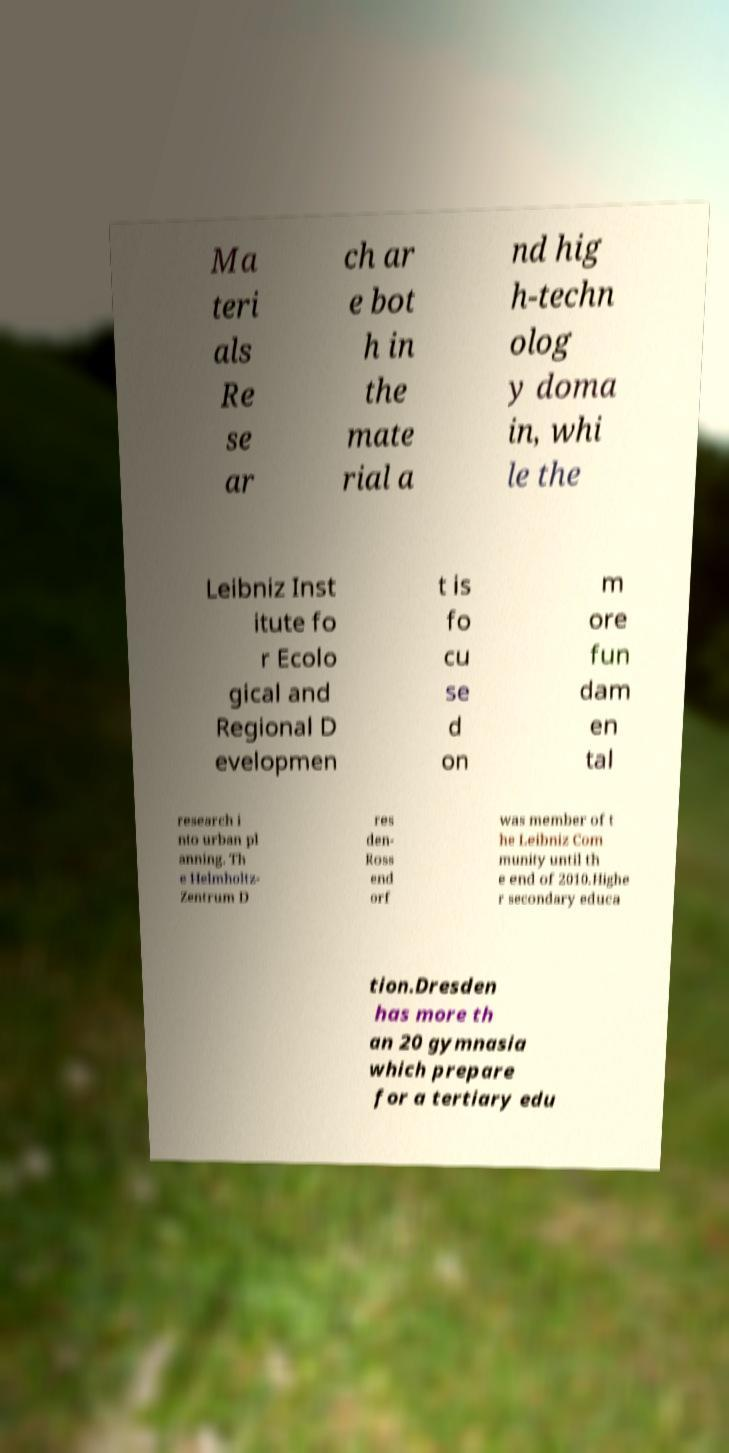Please identify and transcribe the text found in this image. Ma teri als Re se ar ch ar e bot h in the mate rial a nd hig h-techn olog y doma in, whi le the Leibniz Inst itute fo r Ecolo gical and Regional D evelopmen t is fo cu se d on m ore fun dam en tal research i nto urban pl anning. Th e Helmholtz- Zentrum D res den- Ross end orf was member of t he Leibniz Com munity until th e end of 2010.Highe r secondary educa tion.Dresden has more th an 20 gymnasia which prepare for a tertiary edu 